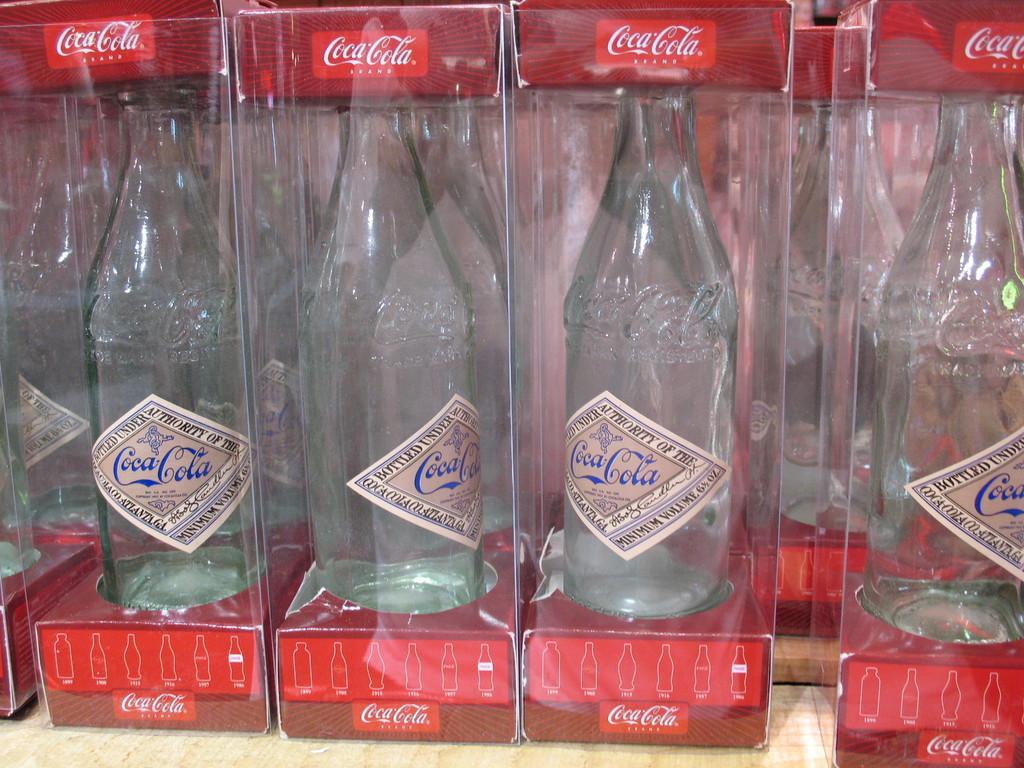Please provide a concise description of this image. In this image i can see few boxes in which there are glass bottles. 